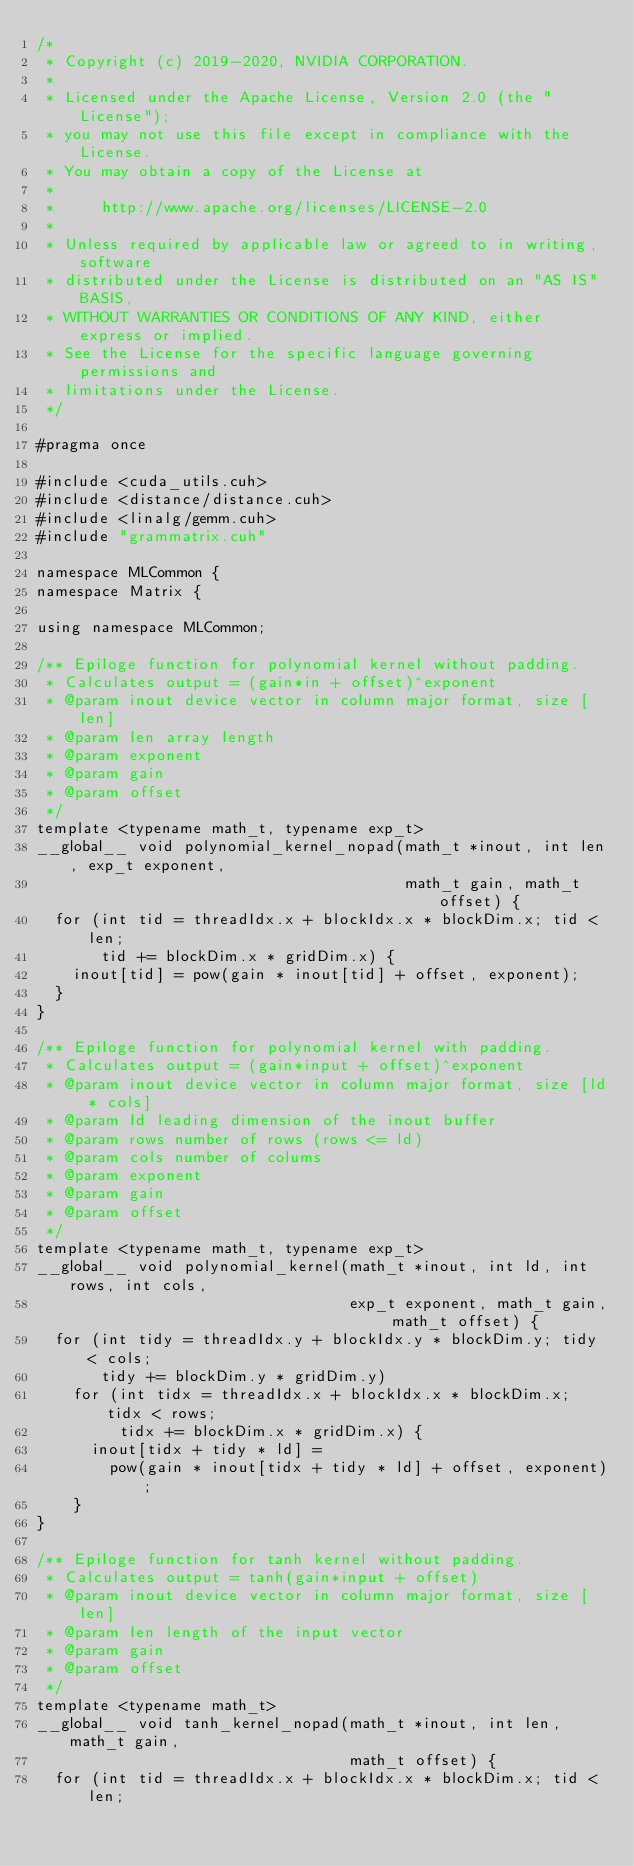<code> <loc_0><loc_0><loc_500><loc_500><_Cuda_>/*
 * Copyright (c) 2019-2020, NVIDIA CORPORATION.
 *
 * Licensed under the Apache License, Version 2.0 (the "License");
 * you may not use this file except in compliance with the License.
 * You may obtain a copy of the License at
 *
 *     http://www.apache.org/licenses/LICENSE-2.0
 *
 * Unless required by applicable law or agreed to in writing, software
 * distributed under the License is distributed on an "AS IS" BASIS,
 * WITHOUT WARRANTIES OR CONDITIONS OF ANY KIND, either express or implied.
 * See the License for the specific language governing permissions and
 * limitations under the License.
 */

#pragma once

#include <cuda_utils.cuh>
#include <distance/distance.cuh>
#include <linalg/gemm.cuh>
#include "grammatrix.cuh"

namespace MLCommon {
namespace Matrix {

using namespace MLCommon;

/** Epiloge function for polynomial kernel without padding.
 * Calculates output = (gain*in + offset)^exponent
 * @param inout device vector in column major format, size [len]
 * @param len array length
 * @param exponent
 * @param gain
 * @param offset
 */
template <typename math_t, typename exp_t>
__global__ void polynomial_kernel_nopad(math_t *inout, int len, exp_t exponent,
                                        math_t gain, math_t offset) {
  for (int tid = threadIdx.x + blockIdx.x * blockDim.x; tid < len;
       tid += blockDim.x * gridDim.x) {
    inout[tid] = pow(gain * inout[tid] + offset, exponent);
  }
}

/** Epiloge function for polynomial kernel with padding.
 * Calculates output = (gain*input + offset)^exponent
 * @param inout device vector in column major format, size [ld * cols]
 * @param ld leading dimension of the inout buffer
 * @param rows number of rows (rows <= ld)
 * @param cols number of colums
 * @param exponent
 * @param gain
 * @param offset
 */
template <typename math_t, typename exp_t>
__global__ void polynomial_kernel(math_t *inout, int ld, int rows, int cols,
                                  exp_t exponent, math_t gain, math_t offset) {
  for (int tidy = threadIdx.y + blockIdx.y * blockDim.y; tidy < cols;
       tidy += blockDim.y * gridDim.y)
    for (int tidx = threadIdx.x + blockIdx.x * blockDim.x; tidx < rows;
         tidx += blockDim.x * gridDim.x) {
      inout[tidx + tidy * ld] =
        pow(gain * inout[tidx + tidy * ld] + offset, exponent);
    }
}

/** Epiloge function for tanh kernel without padding.
 * Calculates output = tanh(gain*input + offset)
 * @param inout device vector in column major format, size [len]
 * @param len length of the input vector
 * @param gain
 * @param offset
 */
template <typename math_t>
__global__ void tanh_kernel_nopad(math_t *inout, int len, math_t gain,
                                  math_t offset) {
  for (int tid = threadIdx.x + blockIdx.x * blockDim.x; tid < len;</code> 